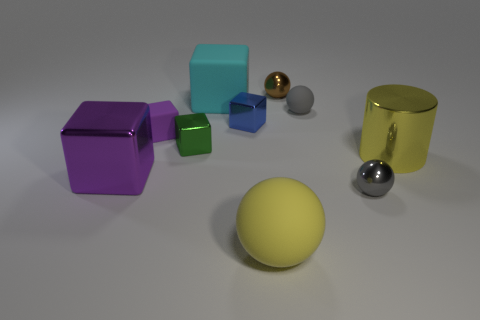Subtract 2 cubes. How many cubes are left? 3 Subtract all yellow blocks. Subtract all gray spheres. How many blocks are left? 5 Subtract all balls. How many objects are left? 6 Subtract 0 cyan balls. How many objects are left? 10 Subtract all red rubber blocks. Subtract all large yellow cylinders. How many objects are left? 9 Add 9 big cylinders. How many big cylinders are left? 10 Add 7 metallic cylinders. How many metallic cylinders exist? 8 